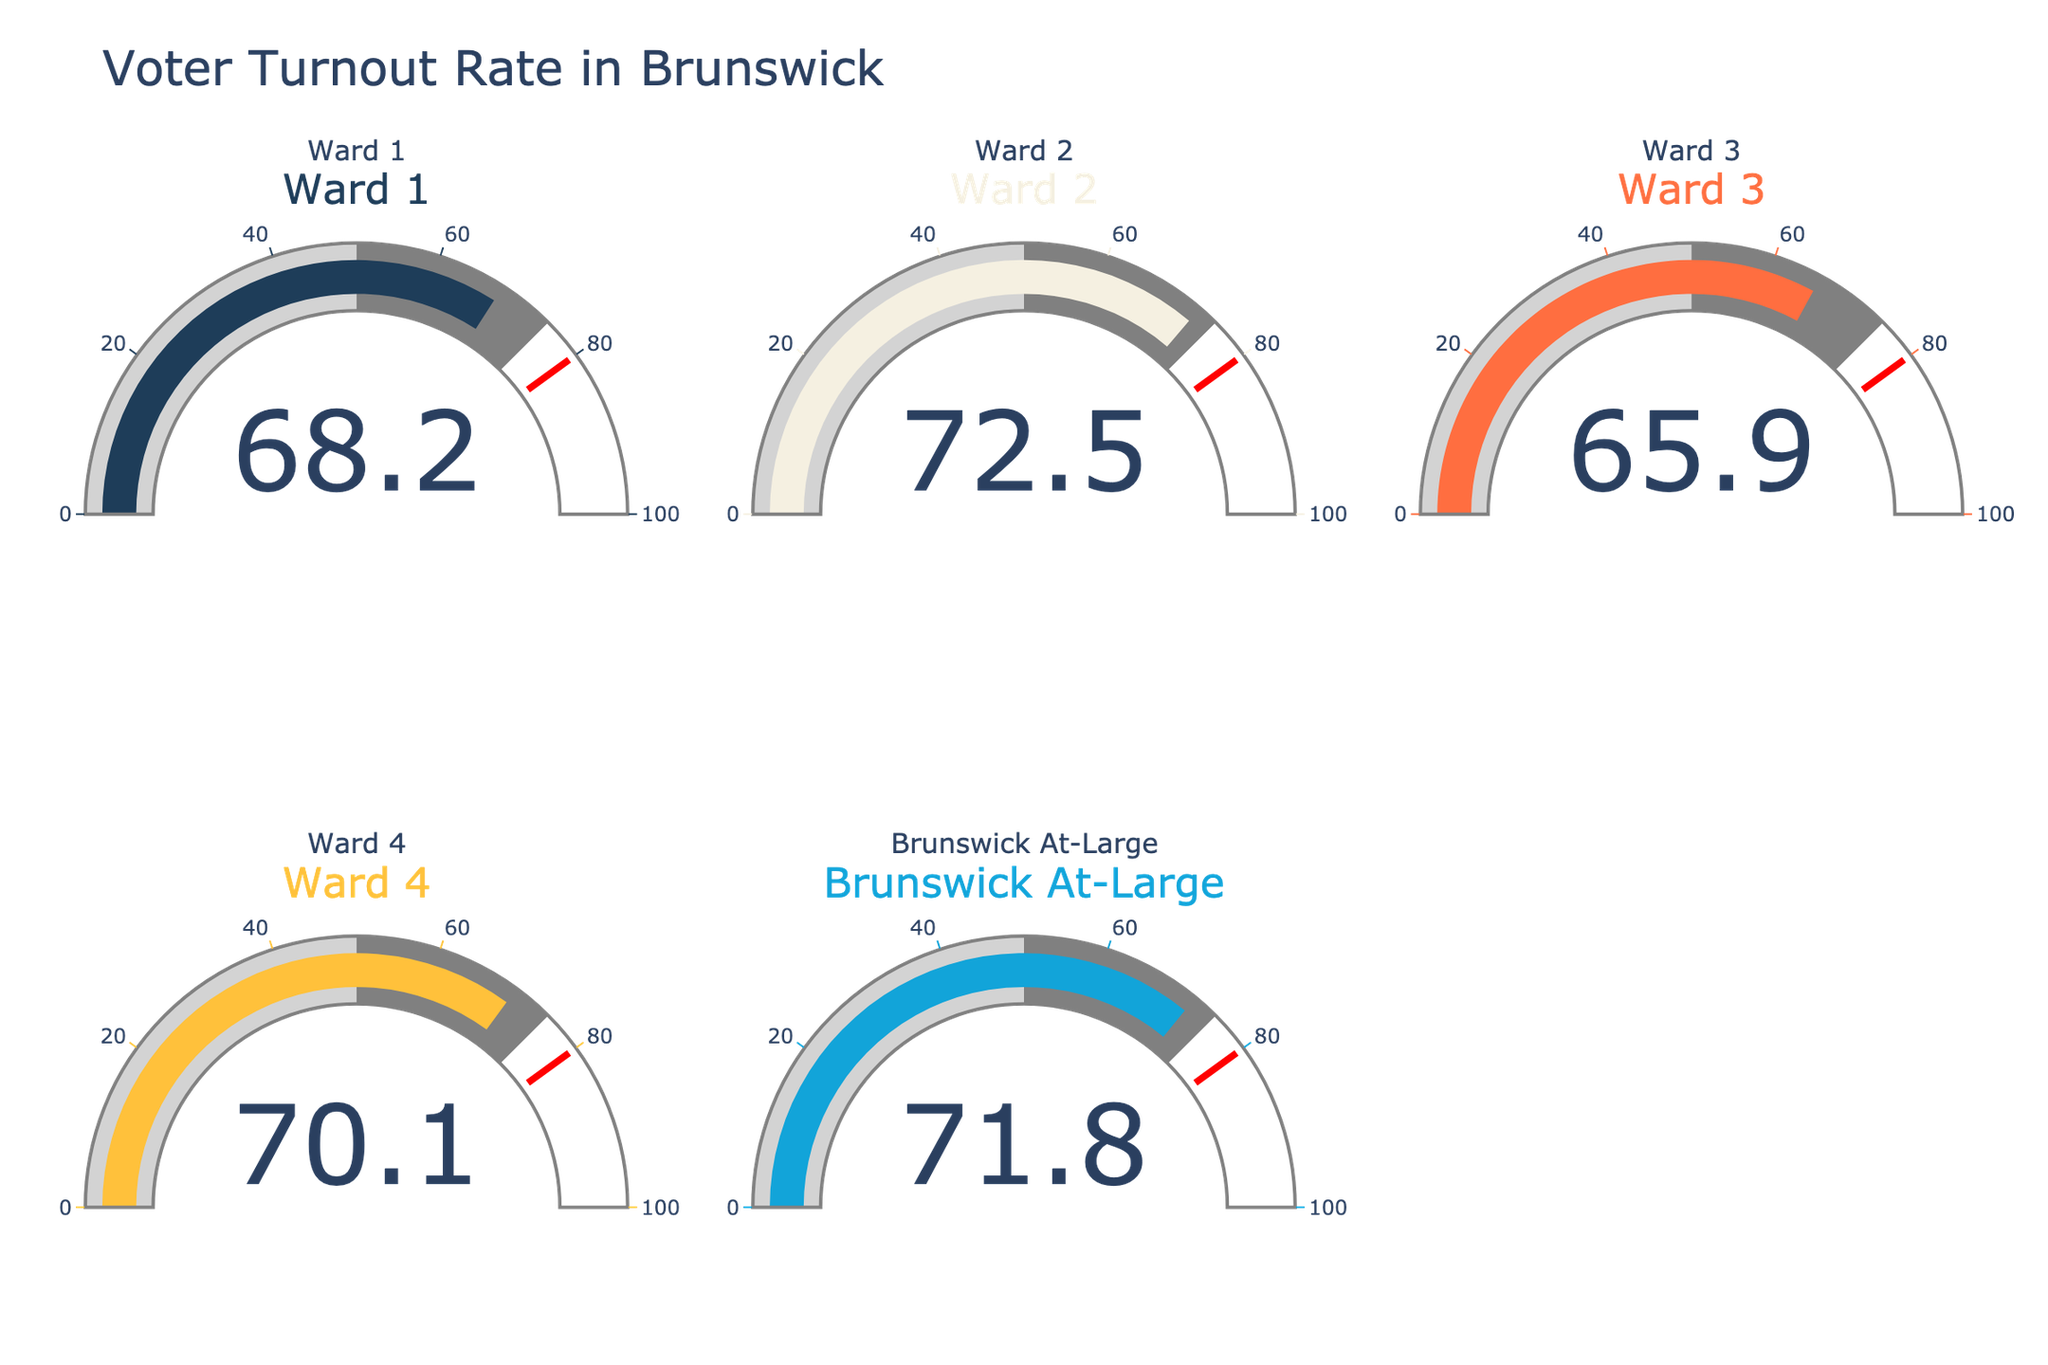What is the voter turnout rate in Ward 1? Look at the gauge for Ward 1 in the figure, which shows a single number representing voter turnout.
Answer: 68.2 How does the turnout rate in Ward 4 compare to that in Brunswick At-Large? Examine the gauges for Ward 4 and Brunswick At-Large. Ward 4 shows 70.1, while Brunswick At-Large shows 71.8.
Answer: Brunswick At-Large is 1.7 percentage points higher Which ward has the lowest voter turnout rate? Identify the lowest value among all the gauges for the wards. Ward 3 shows 65.9, which is the lowest.
Answer: Ward 3 What is the average voter turnout rate across all wards? Sum the turnout rates of all wards and divide by the number of wards. That is, (68.2 + 72.5 + 65.9 + 70.1 + 71.8) / 5 = 348.5 / 5.
Answer: 69.7 What is the difference in voter turnout rate between the highest and lowest wards? Identify the highest (Ward 2 with 72.5) and lowest (Ward 3 with 65.9) values, then subtract the lowest from the highest. 72.5 - 65.9 = 6.6
Answer: 6.6 Which wards have a voter turnout rate above 70%? Check which gauges show values above 70. Wards 2, 4, and Brunswick At-Large have figures above 70.
Answer: Ward 2, Ward 4, Brunswick At-Large Is the overall voter turnout rate closer to 50%, 75%, or 100%? Compare the average voter turnout rate calculated earlier (69.7) to the given reference values (50%, 75%, and 100%). 69.7 is closer to 75%.
Answer: Closer to 75% What is the sum of the voter turnout rates for all wards? Add up all the voter turnout rates: 68.2 + 72.5 + 65.9 + 70.1 + 71.8 = 348.5.
Answer: 348.5 Are all wards above the 50% voter turnout rate threshold? Check each gauge to ensure all values are greater than 50. All indicated values exceed 50%.
Answer: Yes 